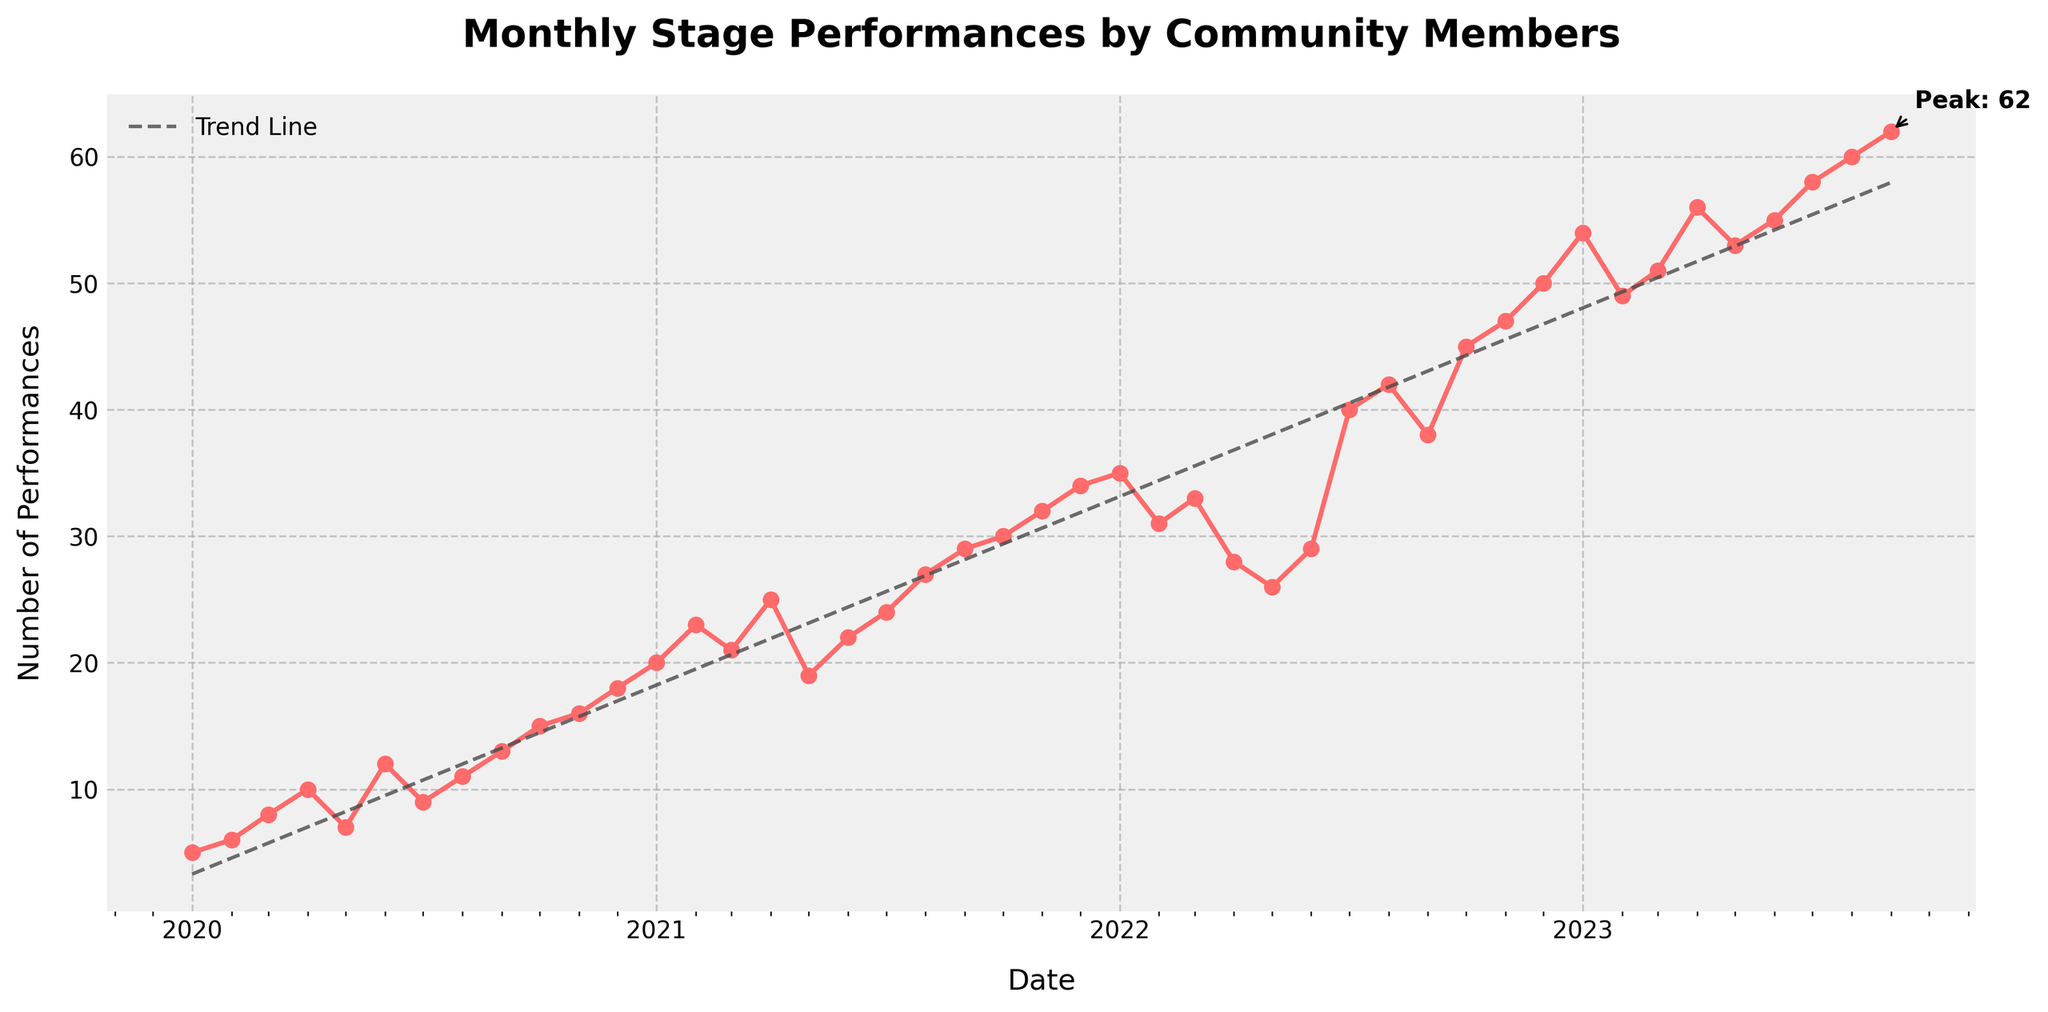What is the title of the plot? The title is located at the top center of the plot and it provides an overview of what the plot represents. It states "Monthly Stage Performances by Community Members".
Answer: Monthly Stage Performances by Community Members What is the trend over the past three years? To determine the trend, look at how the number of performances changes over time. Overall, the number of performances appears to be increasing. This can also be confirmed by the trend line in the plot.
Answer: Increasing What is the highest number of performances recorded in a month, and when did it occur? The plot has an annotation pointing to the peak performance, which gives the specific number and date. It's labeled "Peak: 62" and corresponds to the date "2023-09".
Answer: 62 in September 2023 How many performances occurred in December 2020? Look for the data point corresponding to December 2020 on the x-axis and read the performance count on the y-axis. The performance count for 2020-12 is 18.
Answer: 18 What months and years show a decrease in the number of performances from the previous month? To find this, examine the plot for months where the performance count goes down compared to the previous month. Significant drops occur from January 2023 to February 2023 (54 to 49) and from February 2022 to March 2022 (35 to 31).
Answer: February 2023 and March 2022 Compare the number of performances in January across the three years. Which year had the highest count? Examine the data points for January 2020, 2021, and 2022. The values are 5 (2020), 20 (2021), and 35 (2022). 2022 has the highest count.
Answer: 2022 What is the average number of performances in 2021? Sum the number of performances for each month in 2021 and divide by 12. The performance counts are: 20, 23, 21, 25, 19, 22, 24, 27, 29, 30, 32, 34. The total is 306, so the average is 306 / 12 = 25.5
Answer: 25.5 Which month showed the greatest increase in performances compared to the previous month? Inspect the plot to find where the slope is steepest. The greatest increase is from July 2022 (40) to August 2022 (42), showing a high number visually but for exact increment check other months and correct if necessary. Based on the provided data, it is July 2022 to August 2022.
Answer: July 2022 to August 2022 What is the visual color used for the line connecting the data points? The line connecting the data points is visually distinct and appears using a specific color. In this case, it is a shade of red (#FF6B6B).
Answer: Red Is there a visible trend line on the plot, and what does it suggest about future performance counts? The plot includes a dashed trend line which helps to visualize the overall trend over time. The trend line is increasing, suggesting that future performance counts may continue to rise.
Answer: Yes, suggests increasing performances 